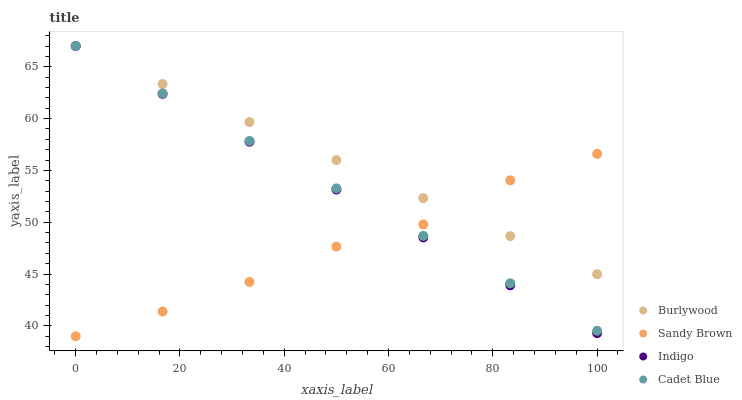Does Sandy Brown have the minimum area under the curve?
Answer yes or no. Yes. Does Burlywood have the maximum area under the curve?
Answer yes or no. Yes. Does Indigo have the minimum area under the curve?
Answer yes or no. No. Does Indigo have the maximum area under the curve?
Answer yes or no. No. Is Indigo the smoothest?
Answer yes or no. Yes. Is Sandy Brown the roughest?
Answer yes or no. Yes. Is Sandy Brown the smoothest?
Answer yes or no. No. Is Cadet Blue the roughest?
Answer yes or no. No. Does Sandy Brown have the lowest value?
Answer yes or no. Yes. Does Indigo have the lowest value?
Answer yes or no. No. Does Cadet Blue have the highest value?
Answer yes or no. Yes. Does Sandy Brown have the highest value?
Answer yes or no. No. Does Sandy Brown intersect Indigo?
Answer yes or no. Yes. Is Sandy Brown less than Indigo?
Answer yes or no. No. Is Sandy Brown greater than Indigo?
Answer yes or no. No. 